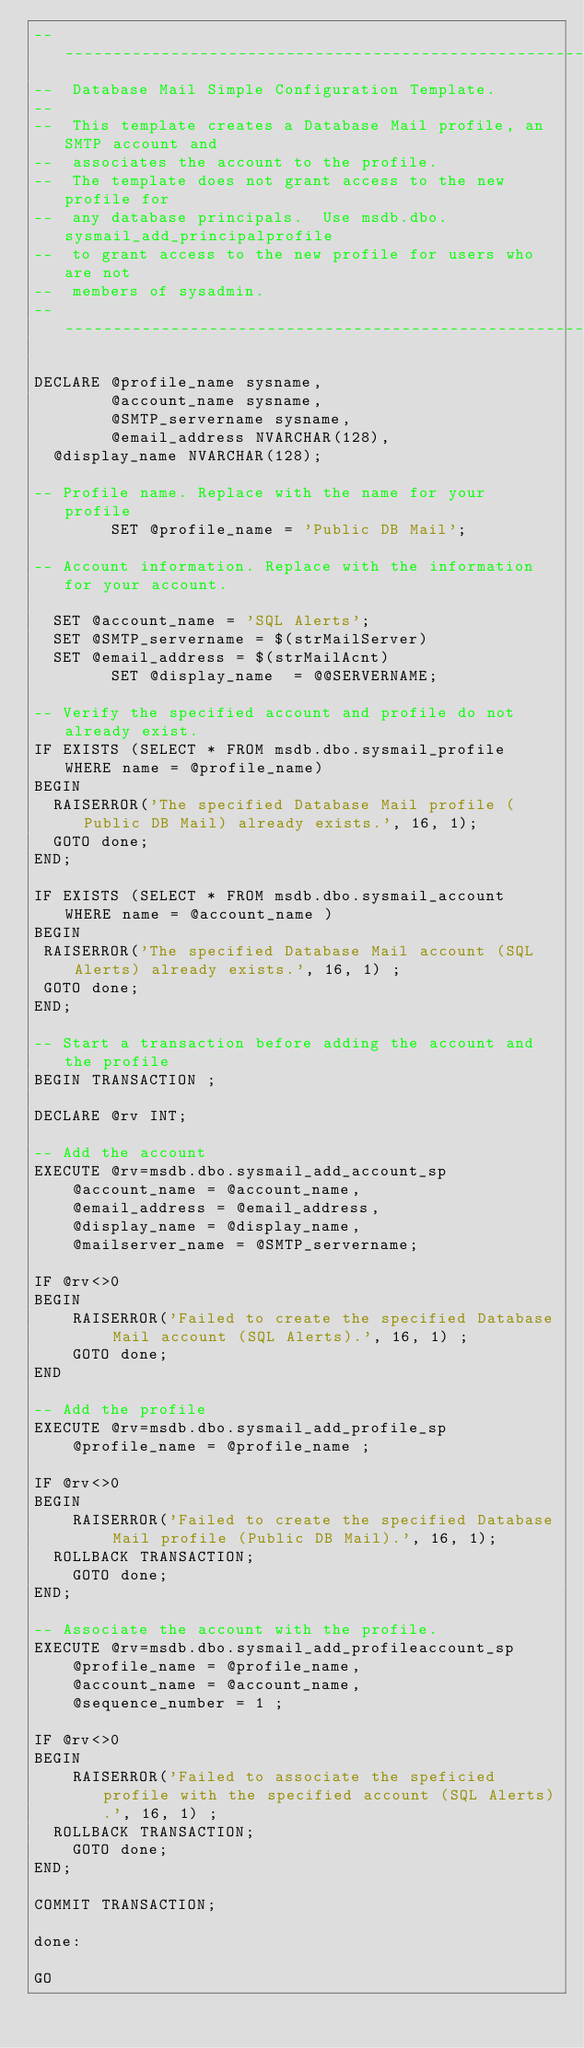<code> <loc_0><loc_0><loc_500><loc_500><_SQL_>-------------------------------------------------------------
--  Database Mail Simple Configuration Template.
--
--  This template creates a Database Mail profile, an SMTP account and 
--  associates the account to the profile.
--  The template does not grant access to the new profile for
--  any database principals.  Use msdb.dbo.sysmail_add_principalprofile
--  to grant access to the new profile for users who are not
--  members of sysadmin.
-------------------------------------------------------------

DECLARE @profile_name sysname,
        @account_name sysname,
        @SMTP_servername sysname,
        @email_address NVARCHAR(128),
	@display_name NVARCHAR(128);

-- Profile name. Replace with the name for your profile
        SET @profile_name = 'Public DB Mail';

-- Account information. Replace with the information for your account.

	SET @account_name = 'SQL Alerts';
	SET @SMTP_servername = $(strMailServer)
	SET @email_address = $(strMailAcnt)
        SET @display_name  = @@SERVERNAME;

-- Verify the specified account and profile do not already exist.
IF EXISTS (SELECT * FROM msdb.dbo.sysmail_profile WHERE name = @profile_name)
BEGIN
  RAISERROR('The specified Database Mail profile (Public DB Mail) already exists.', 16, 1);
  GOTO done;
END;

IF EXISTS (SELECT * FROM msdb.dbo.sysmail_account WHERE name = @account_name )
BEGIN
 RAISERROR('The specified Database Mail account (SQL Alerts) already exists.', 16, 1) ;
 GOTO done;
END;

-- Start a transaction before adding the account and the profile
BEGIN TRANSACTION ;

DECLARE @rv INT;

-- Add the account
EXECUTE @rv=msdb.dbo.sysmail_add_account_sp
    @account_name = @account_name,
    @email_address = @email_address,
    @display_name = @display_name,
    @mailserver_name = @SMTP_servername;

IF @rv<>0
BEGIN
    RAISERROR('Failed to create the specified Database Mail account (SQL Alerts).', 16, 1) ;
    GOTO done;
END

-- Add the profile
EXECUTE @rv=msdb.dbo.sysmail_add_profile_sp
    @profile_name = @profile_name ;

IF @rv<>0
BEGIN
    RAISERROR('Failed to create the specified Database Mail profile (Public DB Mail).', 16, 1);
	ROLLBACK TRANSACTION;
    GOTO done;
END;

-- Associate the account with the profile.
EXECUTE @rv=msdb.dbo.sysmail_add_profileaccount_sp
    @profile_name = @profile_name,
    @account_name = @account_name,
    @sequence_number = 1 ;

IF @rv<>0
BEGIN
    RAISERROR('Failed to associate the speficied profile with the specified account (SQL Alerts).', 16, 1) ;
	ROLLBACK TRANSACTION;
    GOTO done;
END;

COMMIT TRANSACTION;

done:

GO</code> 